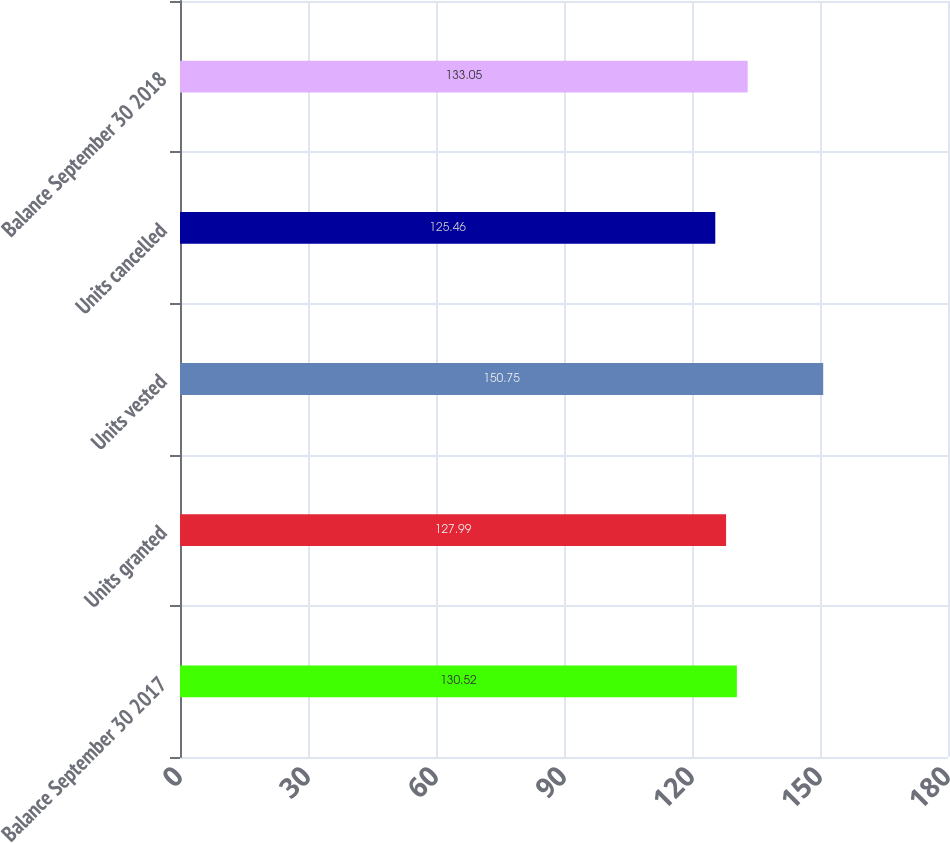Convert chart. <chart><loc_0><loc_0><loc_500><loc_500><bar_chart><fcel>Balance September 30 2017<fcel>Units granted<fcel>Units vested<fcel>Units cancelled<fcel>Balance September 30 2018<nl><fcel>130.52<fcel>127.99<fcel>150.75<fcel>125.46<fcel>133.05<nl></chart> 